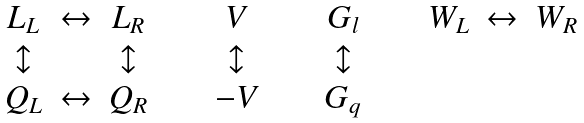Convert formula to latex. <formula><loc_0><loc_0><loc_500><loc_500>\begin{array} { c c c c c c c c c c c } L _ { L } & \leftrightarrow & L _ { R } & \quad & V & \quad & G _ { l } & \quad & W _ { L } & \leftrightarrow & W _ { R } \\ \updownarrow & & \updownarrow & \quad & \updownarrow & \quad & \updownarrow & \quad & & & \\ Q _ { L } & \leftrightarrow & Q _ { R } & \quad & - V & \quad & G _ { q } & \quad & & & \end{array}</formula> 